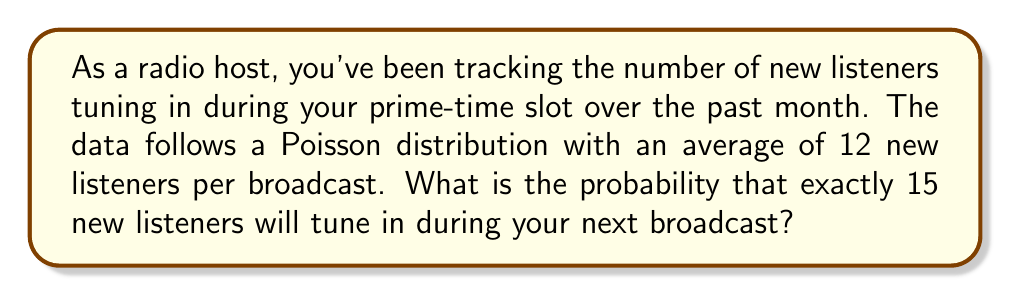Show me your answer to this math problem. To solve this problem, we'll use the Poisson probability mass function:

$$P(X = k) = \frac{e^{-\lambda} \lambda^k}{k!}$$

Where:
$\lambda$ = average number of events (new listeners) per interval
$k$ = number of events we're calculating the probability for
$e$ = Euler's number (approximately 2.71828)

Given:
$\lambda = 12$ (average of 12 new listeners per broadcast)
$k = 15$ (we want exactly 15 new listeners)

Step 1: Plug the values into the Poisson formula:

$$P(X = 15) = \frac{e^{-12} 12^{15}}{15!}$$

Step 2: Calculate the numerator:
$e^{-12} \approx 6.14421 \times 10^{-6}$
$12^{15} = 7.18695 \times 10^{16}$

Step 3: Calculate the denominator:
$15! = 1,307,674,368,000$

Step 4: Divide the numerator by the denominator:

$$P(X = 15) = \frac{(6.14421 \times 10^{-6})(7.18695 \times 10^{16})}{1,307,674,368,000}$$

Step 5: Simplify:

$$P(X = 15) \approx 0.0338$$

Therefore, the probability of exactly 15 new listeners tuning in during your next broadcast is approximately 0.0338 or 3.38%.
Answer: 0.0338 or 3.38% 